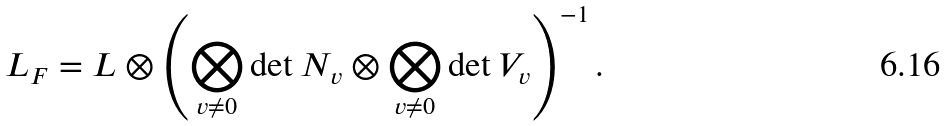Convert formula to latex. <formula><loc_0><loc_0><loc_500><loc_500>L _ { F } = L \otimes \left ( \bigotimes _ { v \neq 0 } \det N _ { v } \otimes \bigotimes _ { v \neq 0 } \det V _ { v } \right ) ^ { - 1 } .</formula> 